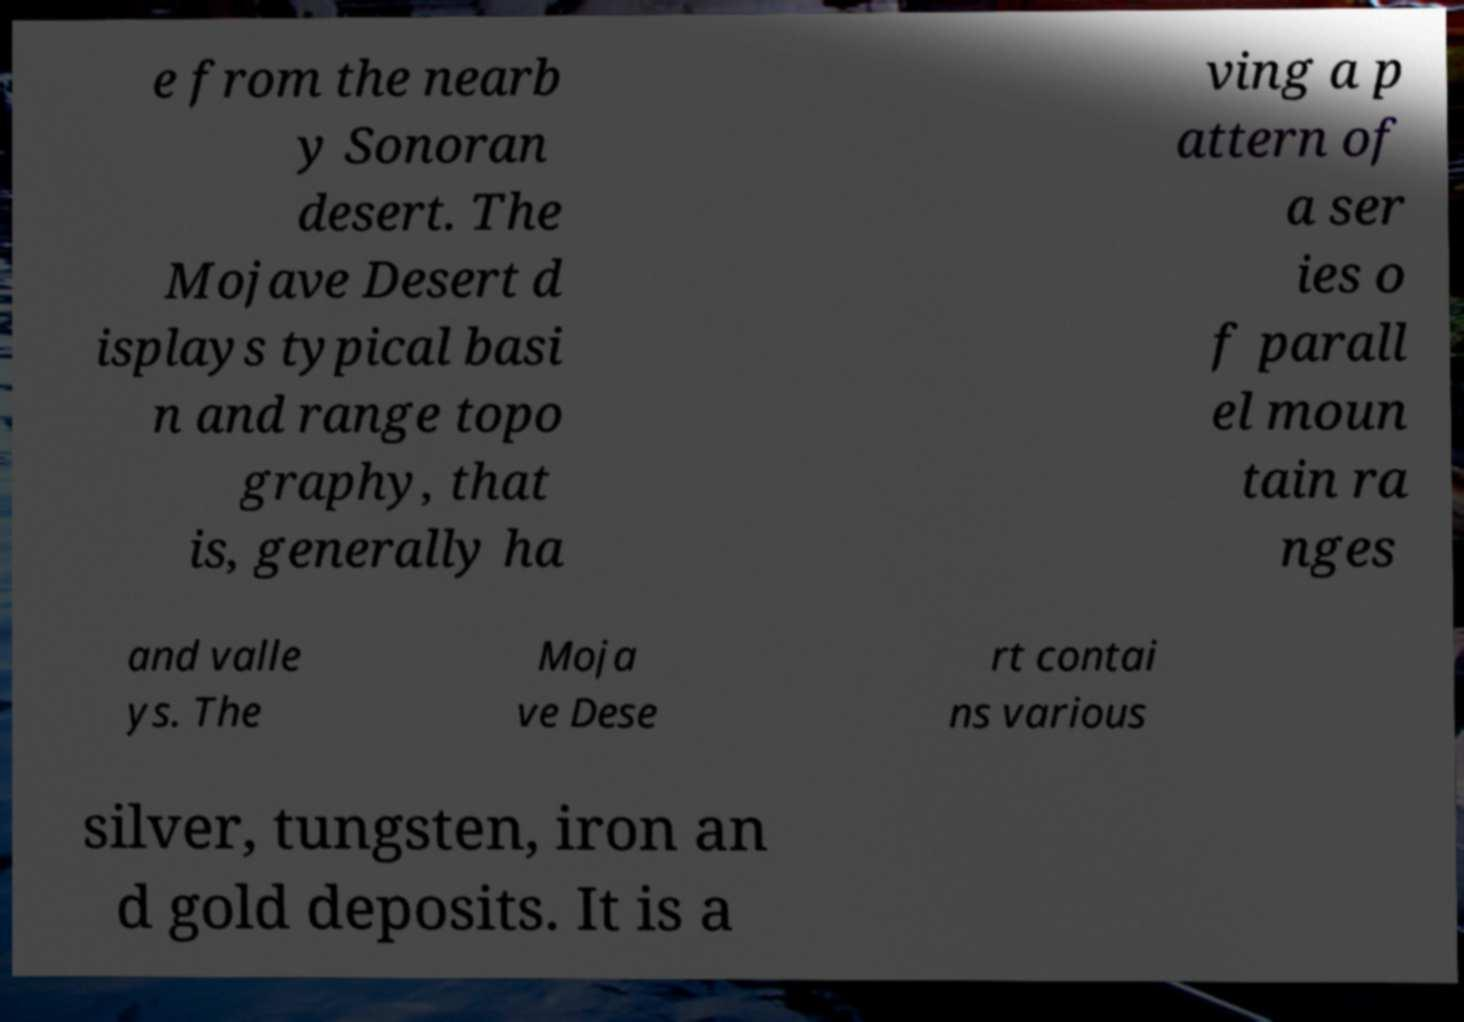For documentation purposes, I need the text within this image transcribed. Could you provide that? e from the nearb y Sonoran desert. The Mojave Desert d isplays typical basi n and range topo graphy, that is, generally ha ving a p attern of a ser ies o f parall el moun tain ra nges and valle ys. The Moja ve Dese rt contai ns various silver, tungsten, iron an d gold deposits. It is a 